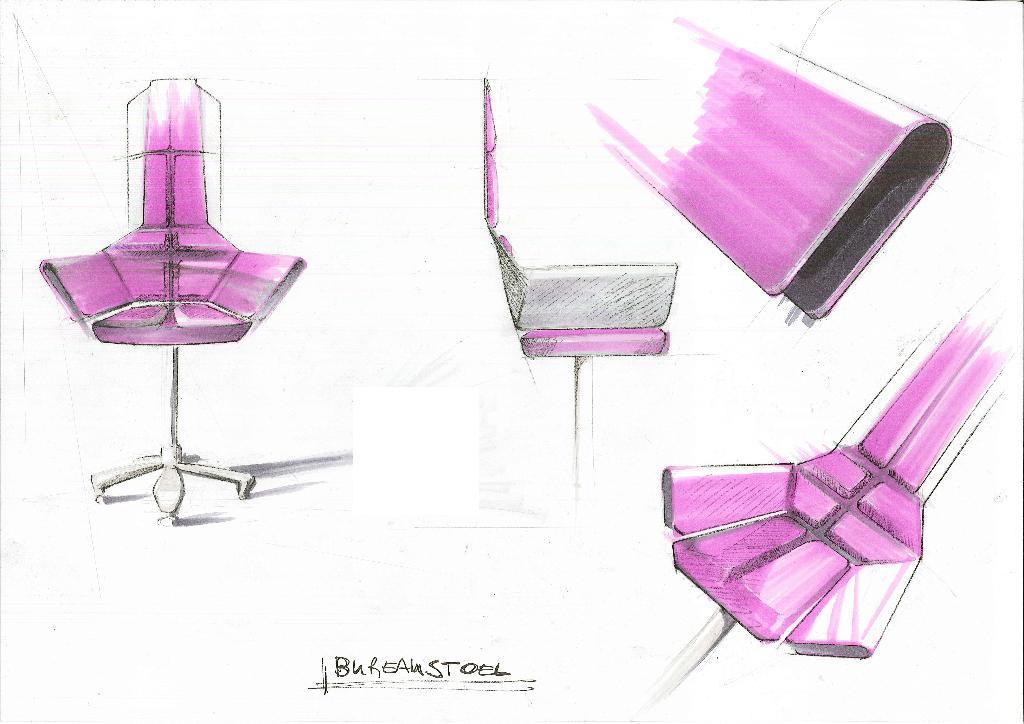Could you give a brief overview of what you see in this image? In this image we can see the drawing of a chair which is in pink color and on the right side, we can see top view and side view of a chair and also we can see some text at the bottom. 